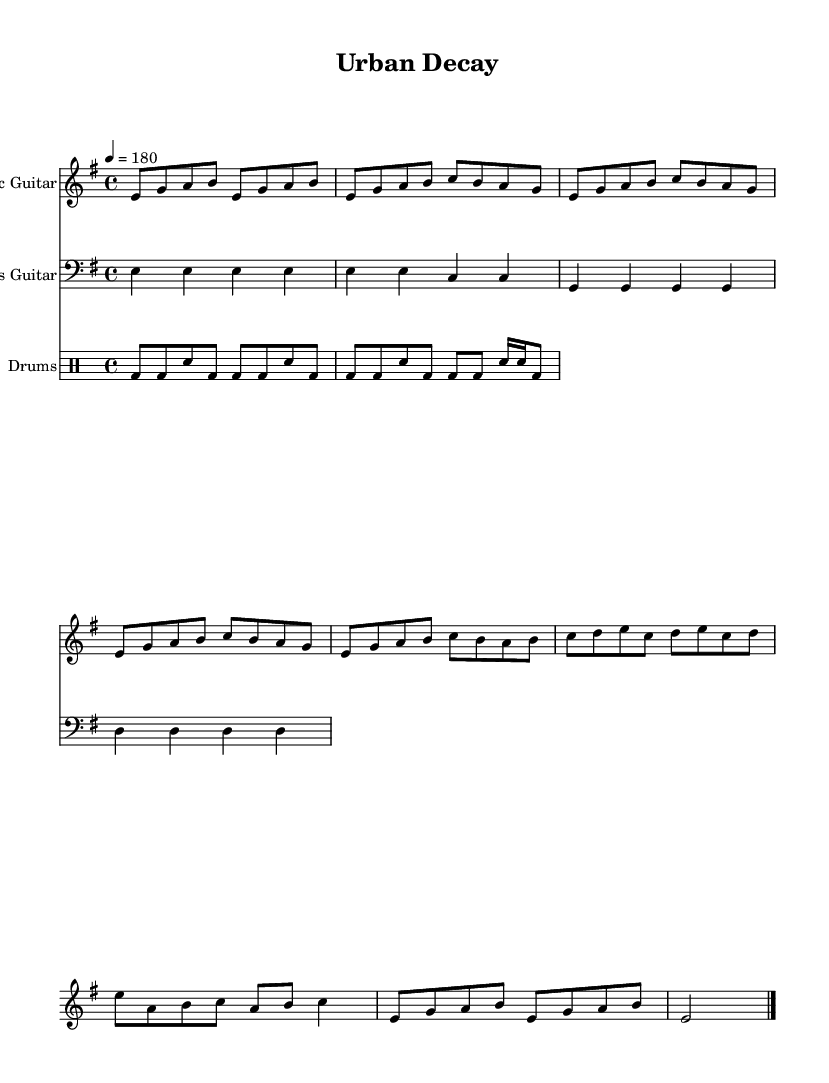What is the key signature of this music? The key signature is E minor, which has one sharp (F#). This can be determined by looking at the `\key` declaration in the LilyPond code.
Answer: E minor What is the time signature of this music? The time signature is 4/4, as indicated by the `\time` declaration in the code. This means there are four beats in each measure.
Answer: 4/4 What is the tempo marking for this piece? The tempo is marked at 180 beats per minute, indicated by the `\tempo` directive in the code, which specifies how fast the music should be played.
Answer: 180 What is the defining rhythm pattern for the drums? The defining rhythm pattern for the drums is the basic punk rock beat, which typically consists of a bass drum on beats 1 and 3, and a snare drum on beats 2 and 4; this can be inferred from the `drummode` section in the code.
Answer: Punk rock beat What is the highest note played in the electric guitar part? The highest note played in the electric guitar part is B, which is found in the introduction and the chorus sections. By examining the pitches listed, the note B is the highest occurring note.
Answer: B What type of instrumentation is featured in this piece? The instrumentation consists of an electric guitar, a bass guitar, and drums, as specified by the `\set Staff.instrumentName` directives in the code for each respective instrument.
Answer: Electric guitar, bass guitar, and drums 